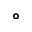Convert formula to latex. <formula><loc_0><loc_0><loc_500><loc_500>^ { \circ }</formula> 